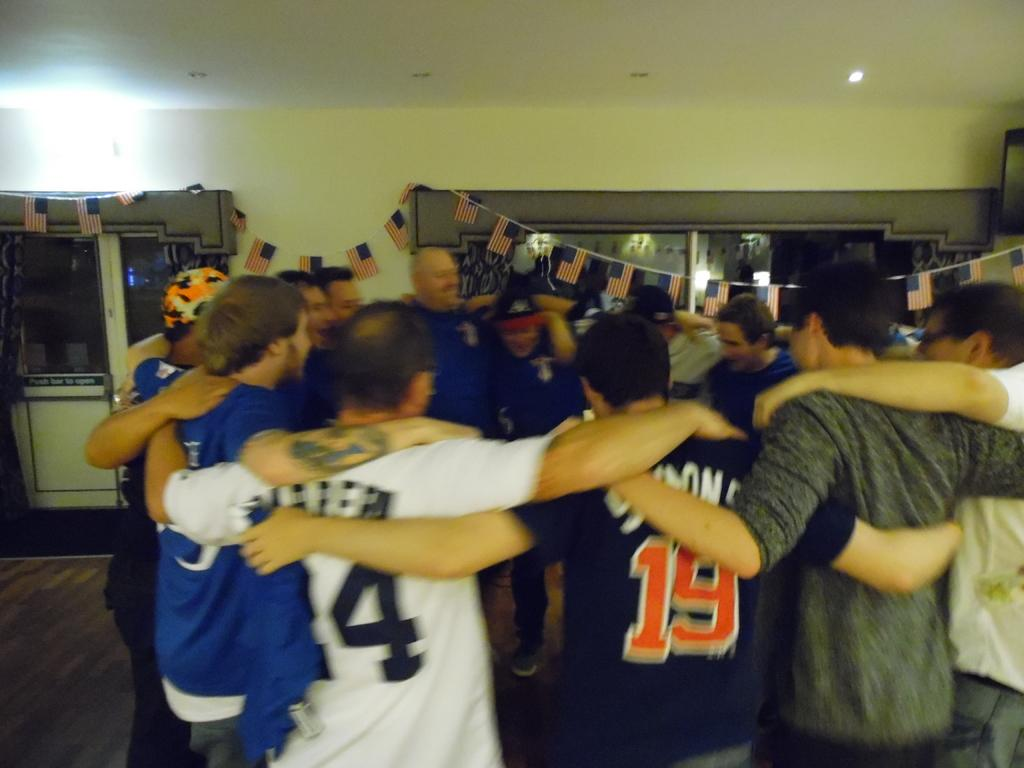<image>
Create a compact narrative representing the image presented. SPORTS TEAM PLAYERS IN A HUDDLE CELEBRATING, ONE WEARING THE NUMBER 19 